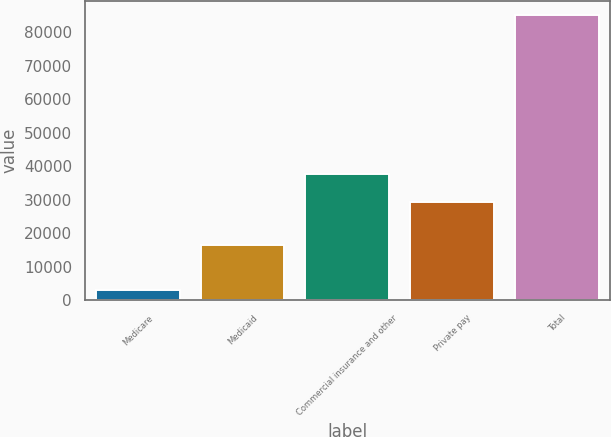<chart> <loc_0><loc_0><loc_500><loc_500><bar_chart><fcel>Medicare<fcel>Medicaid<fcel>Commercial insurance and other<fcel>Private pay<fcel>Total<nl><fcel>2937<fcel>16530<fcel>37610.2<fcel>29381<fcel>85229<nl></chart> 